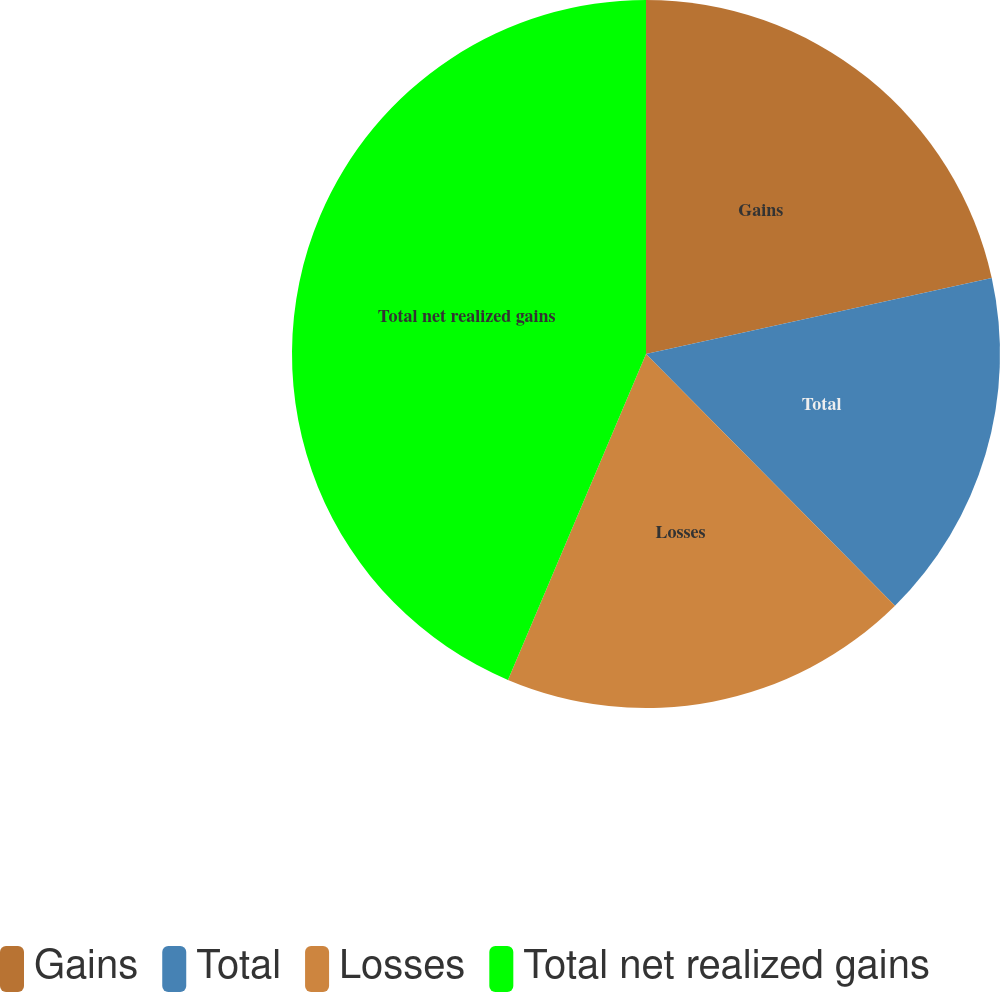<chart> <loc_0><loc_0><loc_500><loc_500><pie_chart><fcel>Gains<fcel>Total<fcel>Losses<fcel>Total net realized gains<nl><fcel>21.55%<fcel>16.03%<fcel>18.79%<fcel>43.62%<nl></chart> 